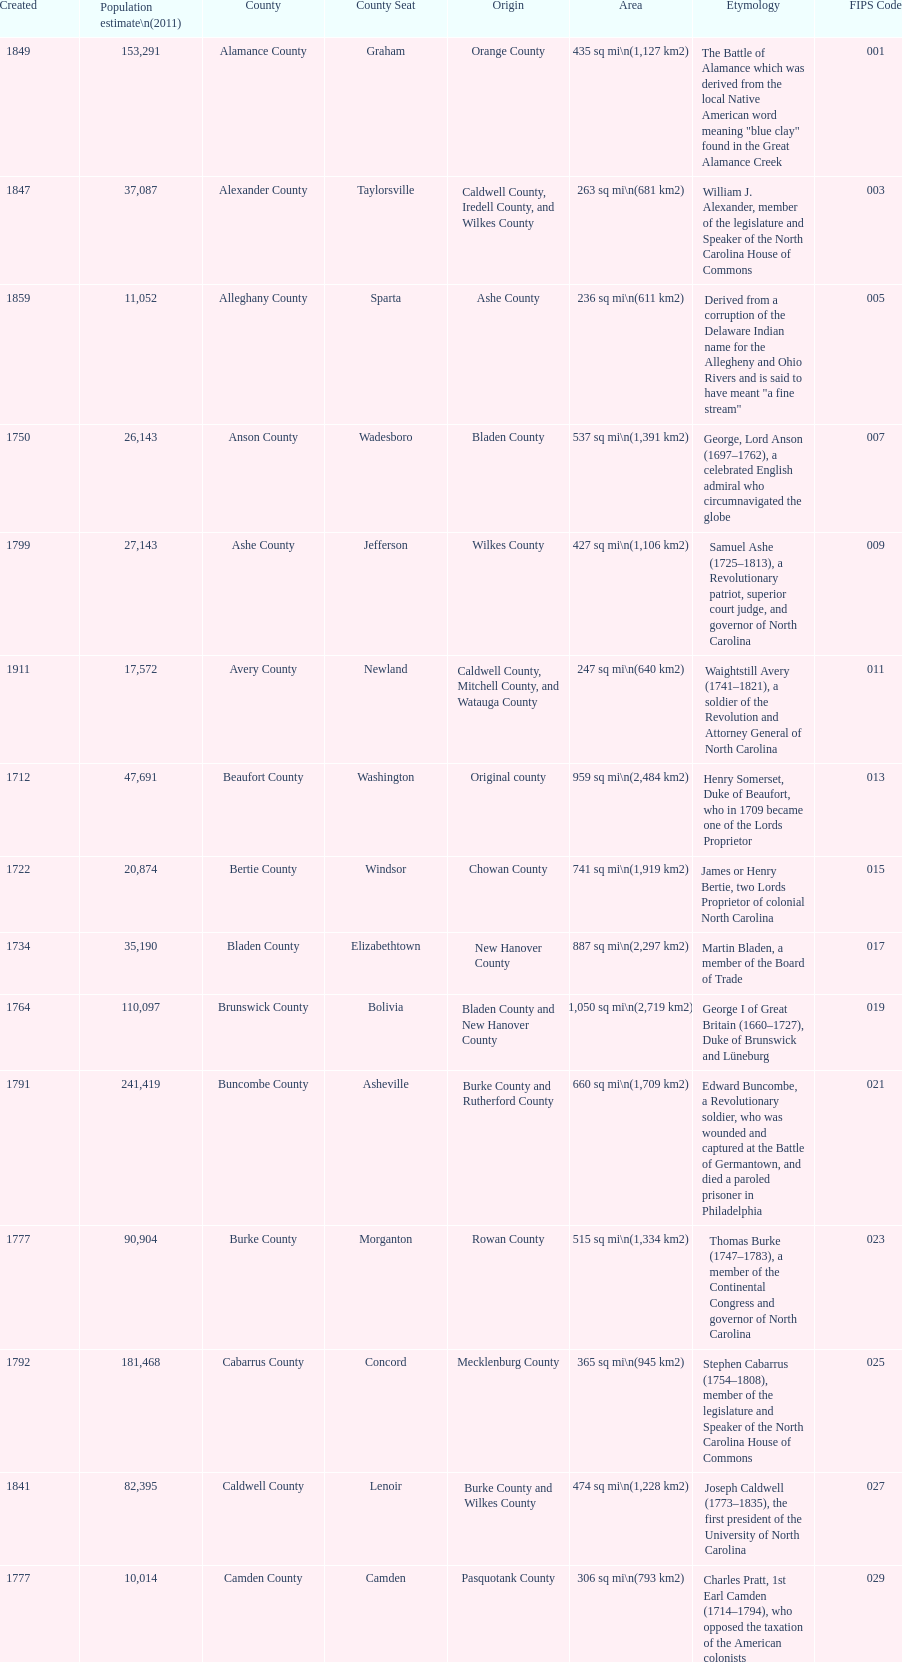What is the total number of counties listed? 100. 